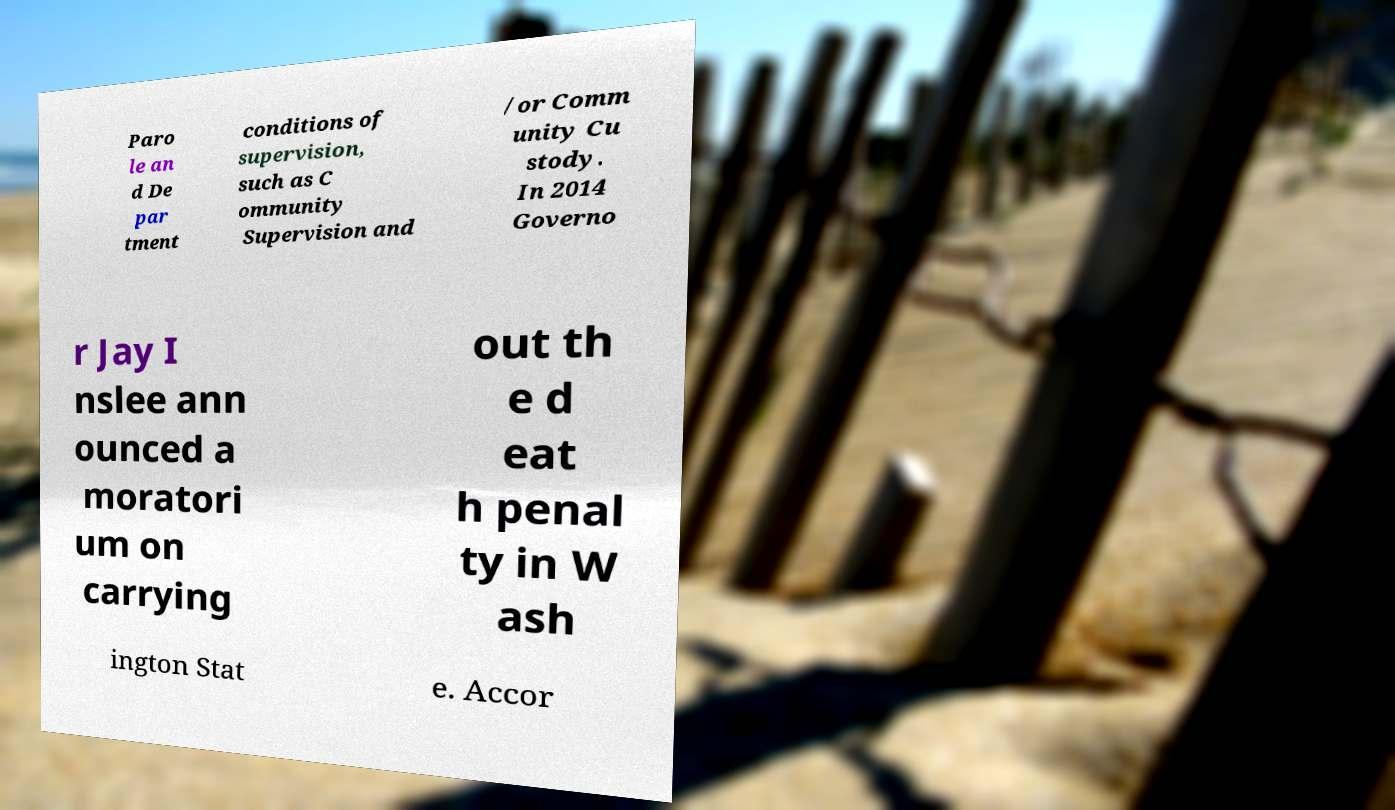Could you assist in decoding the text presented in this image and type it out clearly? Paro le an d De par tment conditions of supervision, such as C ommunity Supervision and /or Comm unity Cu stody. In 2014 Governo r Jay I nslee ann ounced a moratori um on carrying out th e d eat h penal ty in W ash ington Stat e. Accor 